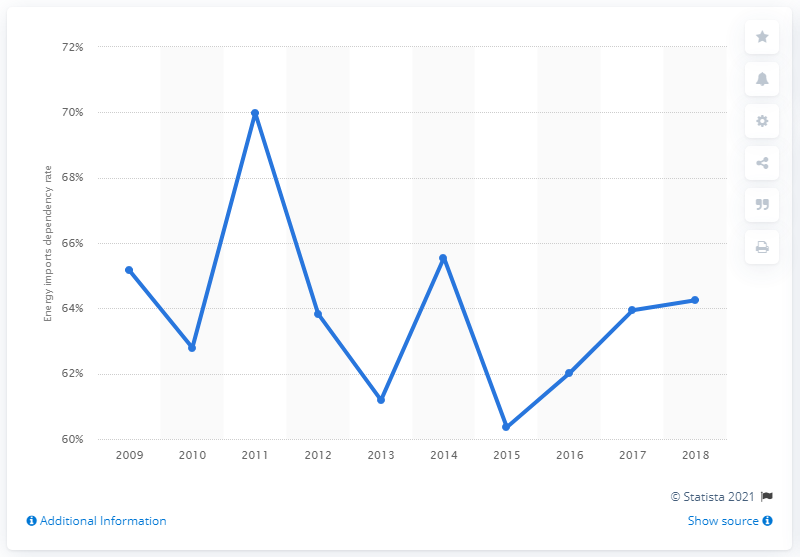Specify some key components in this picture. In 2018, the dependency rate on energy imports in Austria was 64.25%. 